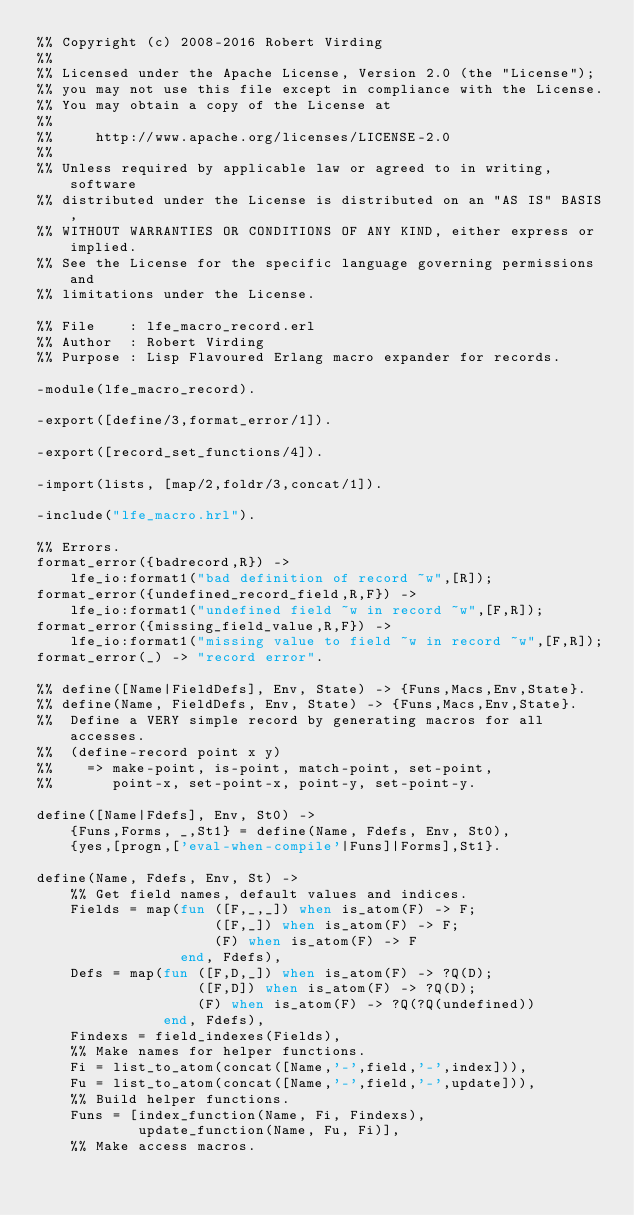<code> <loc_0><loc_0><loc_500><loc_500><_Erlang_>%% Copyright (c) 2008-2016 Robert Virding
%%
%% Licensed under the Apache License, Version 2.0 (the "License");
%% you may not use this file except in compliance with the License.
%% You may obtain a copy of the License at
%%
%%     http://www.apache.org/licenses/LICENSE-2.0
%%
%% Unless required by applicable law or agreed to in writing, software
%% distributed under the License is distributed on an "AS IS" BASIS,
%% WITHOUT WARRANTIES OR CONDITIONS OF ANY KIND, either express or implied.
%% See the License for the specific language governing permissions and
%% limitations under the License.

%% File    : lfe_macro_record.erl
%% Author  : Robert Virding
%% Purpose : Lisp Flavoured Erlang macro expander for records.

-module(lfe_macro_record).

-export([define/3,format_error/1]).

-export([record_set_functions/4]).

-import(lists, [map/2,foldr/3,concat/1]).

-include("lfe_macro.hrl").

%% Errors.
format_error({badrecord,R}) ->
    lfe_io:format1("bad definition of record ~w",[R]);
format_error({undefined_record_field,R,F}) ->
    lfe_io:format1("undefined field ~w in record ~w",[F,R]);
format_error({missing_field_value,R,F}) ->
    lfe_io:format1("missing value to field ~w in record ~w",[F,R]);
format_error(_) -> "record error".

%% define([Name|FieldDefs], Env, State) -> {Funs,Macs,Env,State}.
%% define(Name, FieldDefs, Env, State) -> {Funs,Macs,Env,State}.
%%  Define a VERY simple record by generating macros for all accesses.
%%  (define-record point x y)
%%    => make-point, is-point, match-point, set-point,
%%       point-x, set-point-x, point-y, set-point-y.

define([Name|Fdefs], Env, St0) ->
    {Funs,Forms, _,St1} = define(Name, Fdefs, Env, St0),
    {yes,[progn,['eval-when-compile'|Funs]|Forms],St1}.

define(Name, Fdefs, Env, St) ->
    %% Get field names, default values and indices.
    Fields = map(fun ([F,_,_]) when is_atom(F) -> F;
                     ([F,_]) when is_atom(F) -> F;
                     (F) when is_atom(F) -> F
                 end, Fdefs),
    Defs = map(fun ([F,D,_]) when is_atom(F) -> ?Q(D);
                   ([F,D]) when is_atom(F) -> ?Q(D);
                   (F) when is_atom(F) -> ?Q(?Q(undefined))
               end, Fdefs),
    Findexs = field_indexes(Fields),
    %% Make names for helper functions.
    Fi = list_to_atom(concat([Name,'-',field,'-',index])),
    Fu = list_to_atom(concat([Name,'-',field,'-',update])),
    %% Build helper functions.
    Funs = [index_function(Name, Fi, Findexs),
            update_function(Name, Fu, Fi)],
    %% Make access macros.</code> 